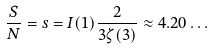Convert formula to latex. <formula><loc_0><loc_0><loc_500><loc_500>\frac { S } { N } = s = I ( 1 ) \frac { 2 } { 3 \zeta ( 3 ) } \approx 4 . 2 0 \dots</formula> 